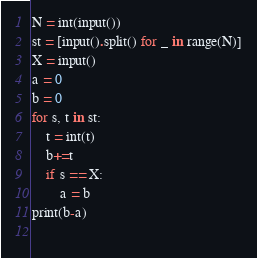Convert code to text. <code><loc_0><loc_0><loc_500><loc_500><_Python_>N = int(input())
st = [input().split() for _ in range(N)]
X = input()
a = 0
b = 0
for s, t in st:
    t = int(t)
    b+=t
    if s == X:
        a = b
print(b-a)
        
</code> 